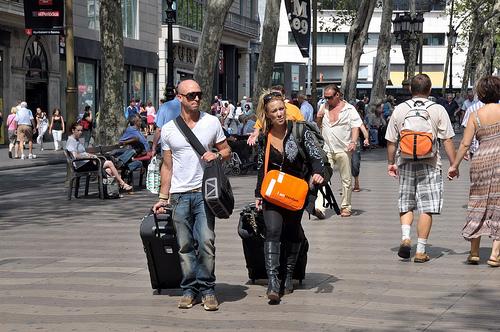Are these people tourists?
Be succinct. Yes. What are these people dragging behind them?
Keep it brief. Suitcases. Is it a warm sunny day?
Quick response, please. Yes. What color is the bag around the woman?
Keep it brief. Orange. Is this picture in color?
Answer briefly. Yes. 